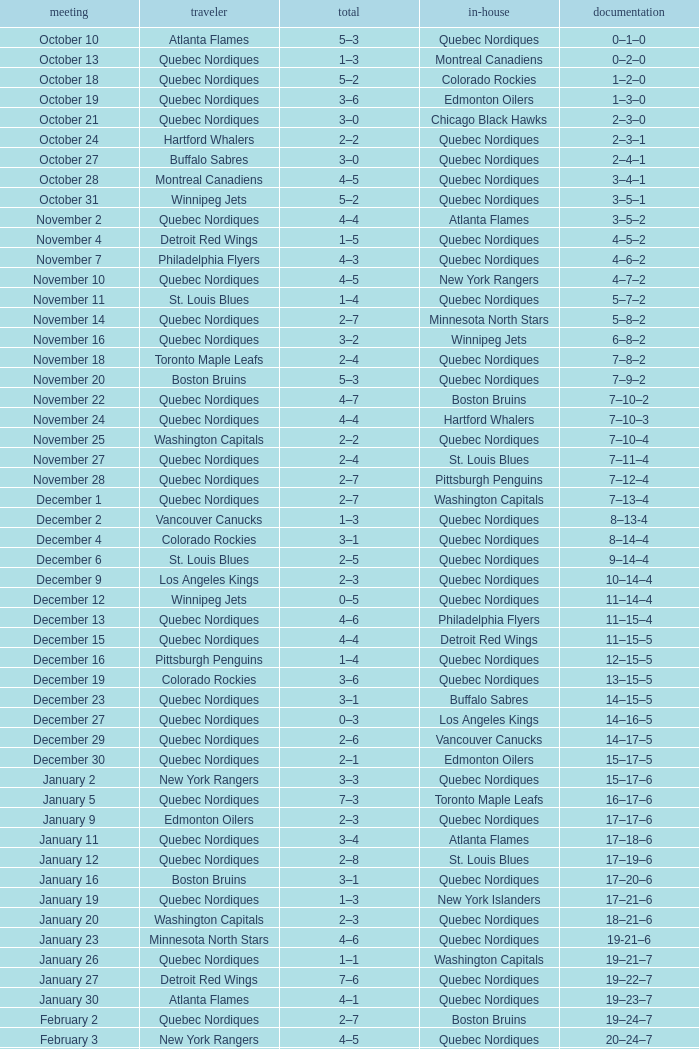Which Record has a Score of 2–4, and a Home of quebec nordiques? 7–8–2. 